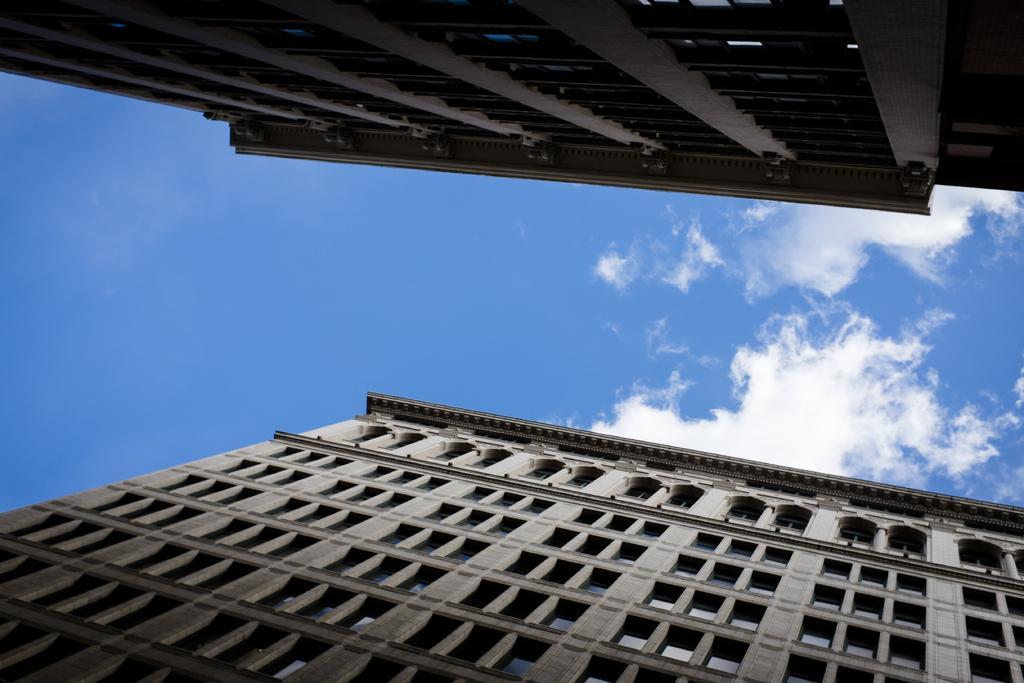Describe this image in one or two sentences. In this image I can see the buildings. In the background I can see the clouds and the blue sky. 